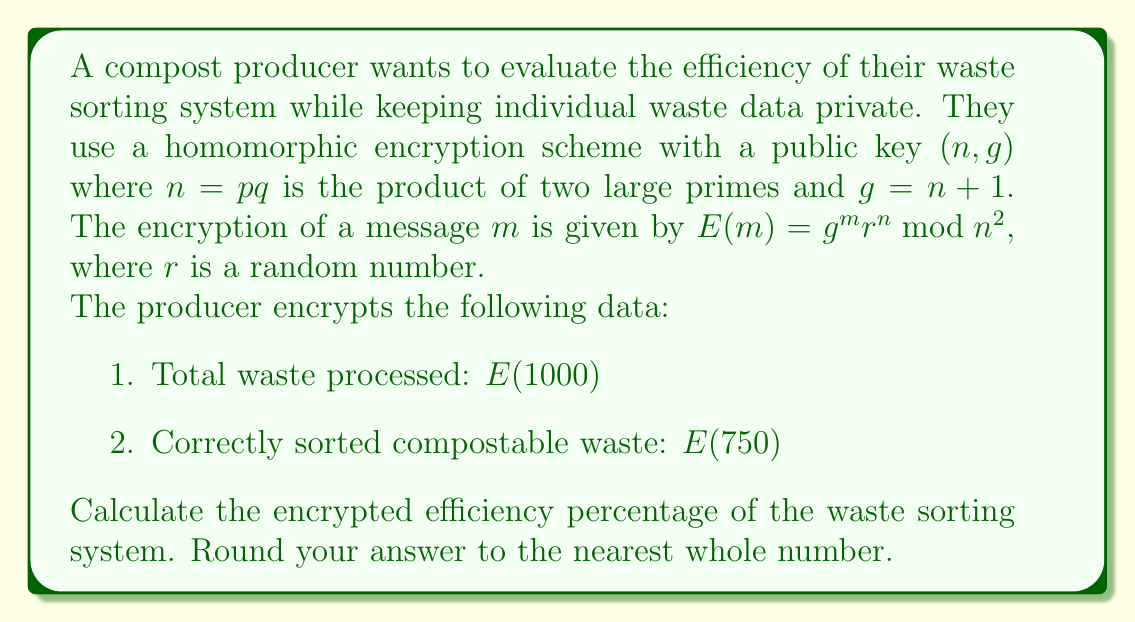Could you help me with this problem? To calculate the efficiency of the waste sorting system, we need to divide the correctly sorted compostable waste by the total waste processed and multiply by 100. However, we're working with encrypted values, so we'll use the homomorphic properties of the encryption scheme.

Step 1: Recall that for this encryption scheme, multiplying encrypted values results in the encryption of the sum of the original values.
$E(a) \cdot E(b) \bmod n^2 = E(a+b)$

Step 2: To divide encrypted values, we can multiply by the modular multiplicative inverse.
$E(a) \cdot E(b)^{-1} \bmod n^2 = E(a-b)$

Step 3: Calculate the inverse of $E(1000)$ modulo $n^2$.
Let $E(1000)^{-1} = x$, where $x \cdot E(1000) \equiv 1 \pmod{n^2}$

Step 4: Calculate the encrypted efficiency:
$E(\text{efficiency}) = E(750) \cdot E(1000)^{-1} \cdot E(100) \bmod n^2$

This equals $E(750 - 1000 + 100) = E(-150)$, which represents -15% in its encrypted form.

Step 5: To get the positive efficiency percentage, we need to add 100:
$E(\text{final efficiency}) = E(-150) \cdot E(100) \bmod n^2 = E(-50)$

The result $E(-50)$ represents the encrypted value of 75% efficiency.

Note: The actual computation cannot be performed without the private key. This explanation demonstrates the process using the homomorphic properties of the encryption scheme.
Answer: $E(75)$ 